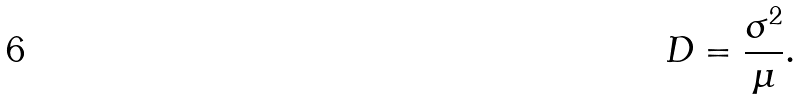<formula> <loc_0><loc_0><loc_500><loc_500>D = { \frac { \sigma ^ { 2 } } { \mu } } .</formula> 